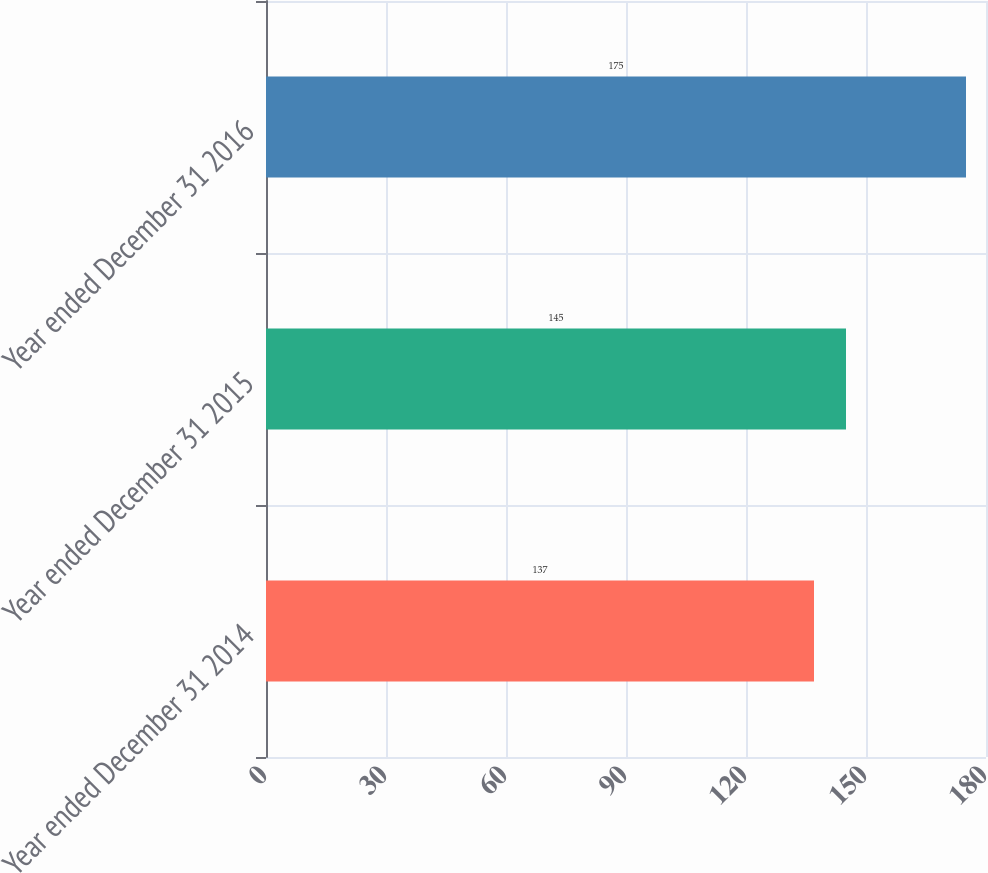Convert chart. <chart><loc_0><loc_0><loc_500><loc_500><bar_chart><fcel>Year ended December 31 2014<fcel>Year ended December 31 2015<fcel>Year ended December 31 2016<nl><fcel>137<fcel>145<fcel>175<nl></chart> 